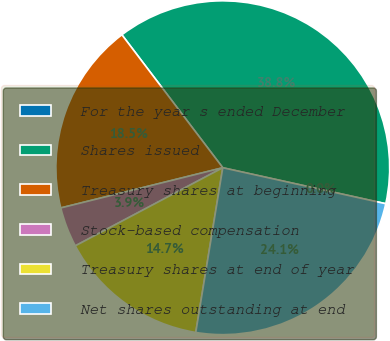Convert chart. <chart><loc_0><loc_0><loc_500><loc_500><pie_chart><fcel>For the year s ended December<fcel>Shares issued<fcel>Treasury shares at beginning<fcel>Stock-based compensation<fcel>Treasury shares at end of year<fcel>Net shares outstanding at end<nl><fcel>0.0%<fcel>38.79%<fcel>18.54%<fcel>3.88%<fcel>14.66%<fcel>24.13%<nl></chart> 